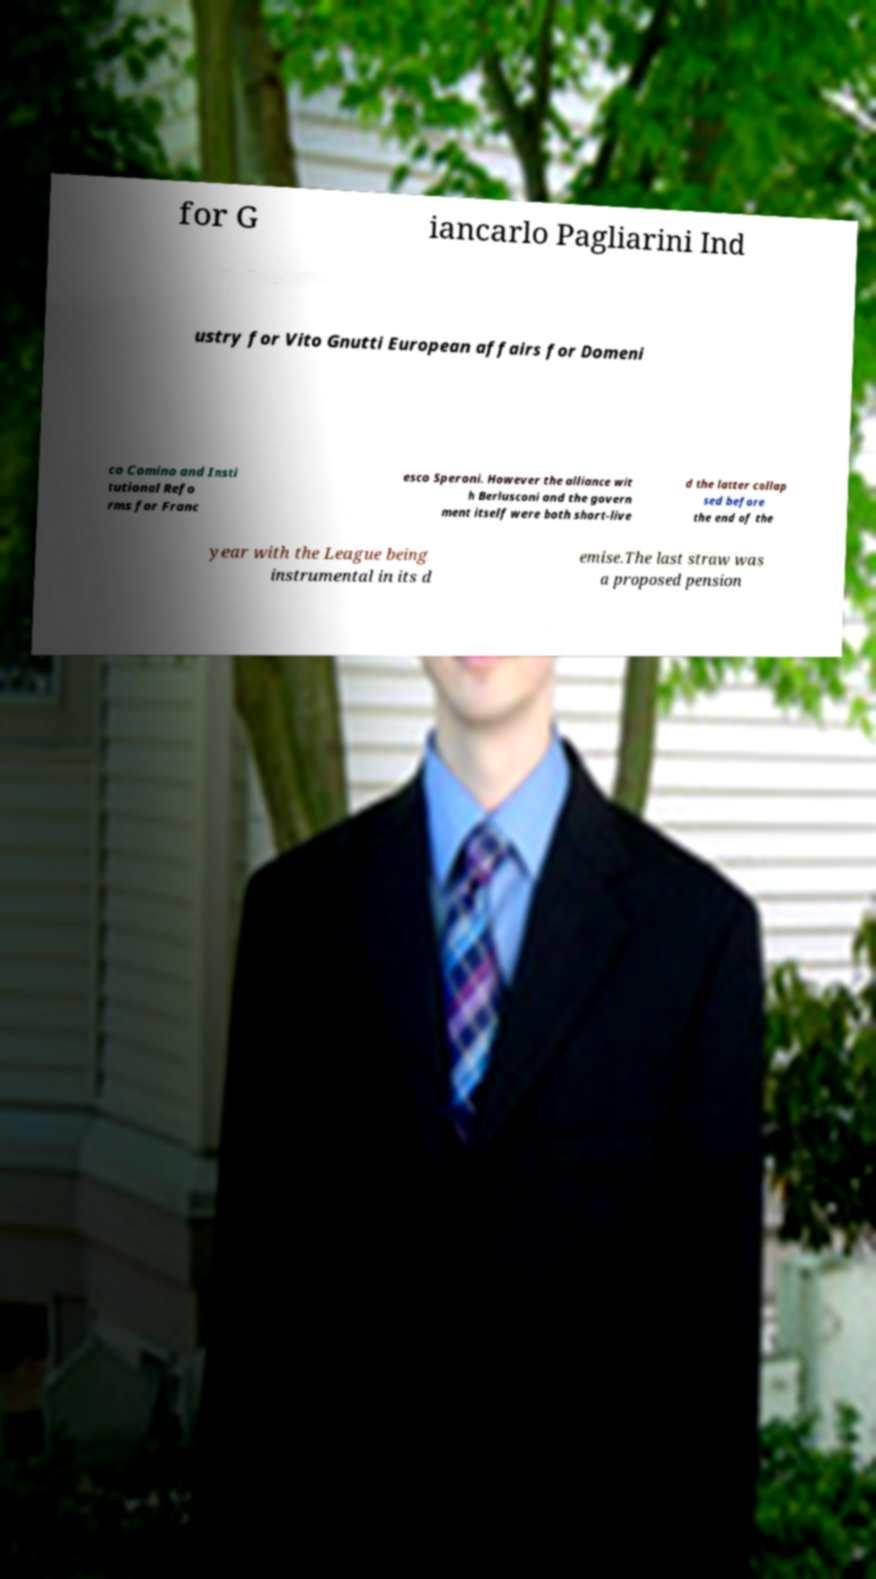What messages or text are displayed in this image? I need them in a readable, typed format. for G iancarlo Pagliarini Ind ustry for Vito Gnutti European affairs for Domeni co Comino and Insti tutional Refo rms for Franc esco Speroni. However the alliance wit h Berlusconi and the govern ment itself were both short-live d the latter collap sed before the end of the year with the League being instrumental in its d emise.The last straw was a proposed pension 